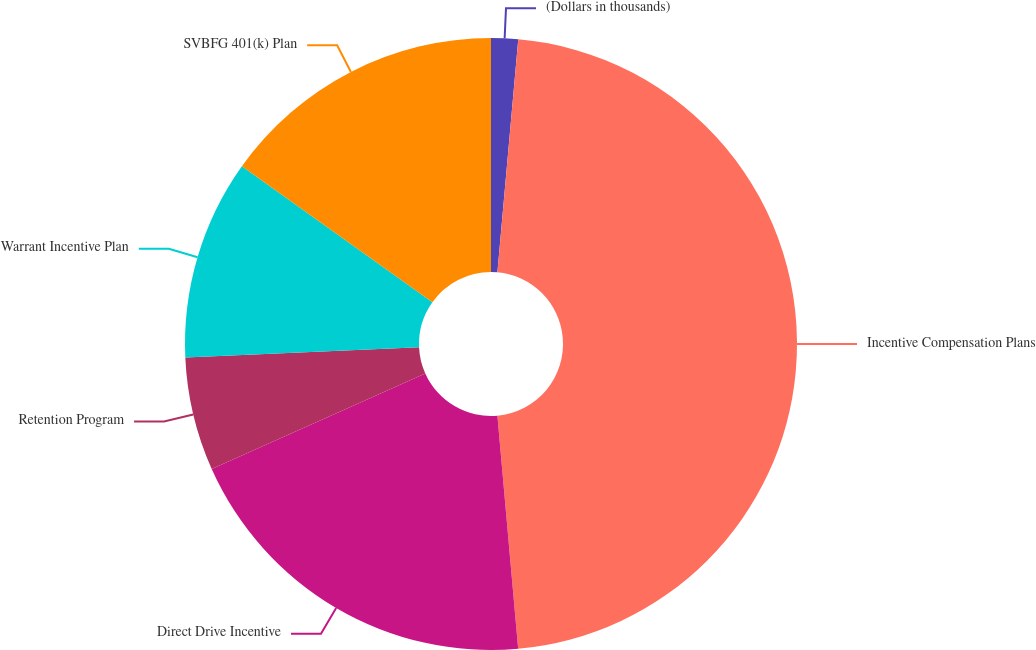Convert chart to OTSL. <chart><loc_0><loc_0><loc_500><loc_500><pie_chart><fcel>(Dollars in thousands)<fcel>Incentive Compensation Plans<fcel>Direct Drive Incentive<fcel>Retention Program<fcel>Warrant Incentive Plan<fcel>SVBFG 401(k) Plan<nl><fcel>1.42%<fcel>47.17%<fcel>19.72%<fcel>5.99%<fcel>10.57%<fcel>15.14%<nl></chart> 